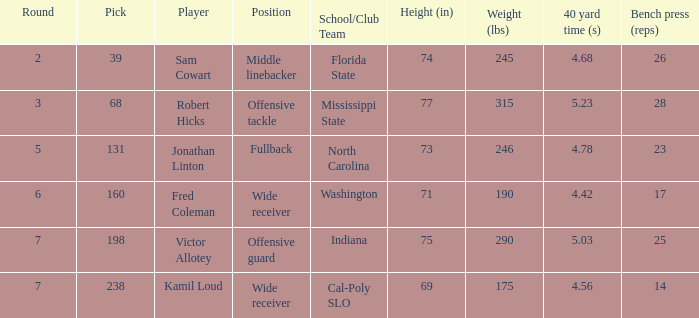Which Round has a School/Club Team of north carolina, and a Pick larger than 131? 0.0. 